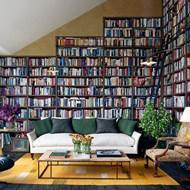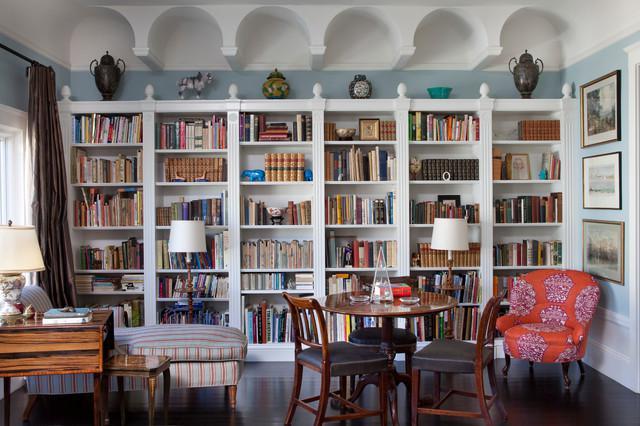The first image is the image on the left, the second image is the image on the right. For the images shown, is this caption "In the left image there is a ladder leaning against the bookcase." true? Answer yes or no. Yes. 